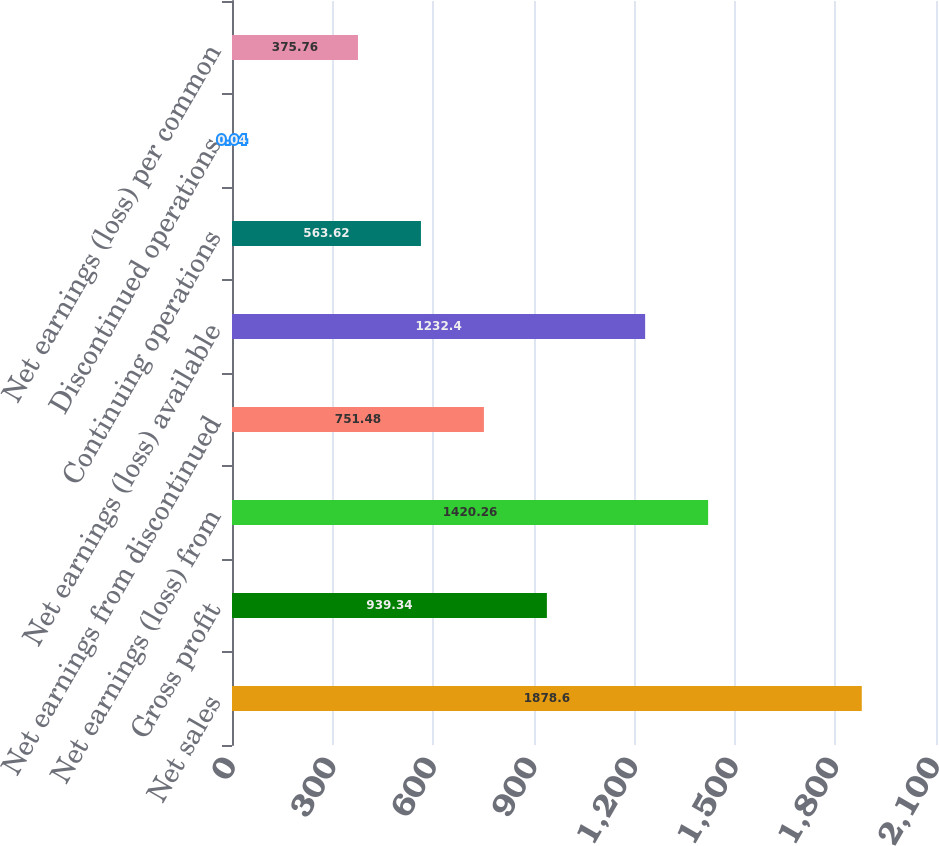Convert chart to OTSL. <chart><loc_0><loc_0><loc_500><loc_500><bar_chart><fcel>Net sales<fcel>Gross profit<fcel>Net earnings (loss) from<fcel>Net earnings from discontinued<fcel>Net earnings (loss) available<fcel>Continuing operations<fcel>Discontinued operations<fcel>Net earnings (loss) per common<nl><fcel>1878.6<fcel>939.34<fcel>1420.26<fcel>751.48<fcel>1232.4<fcel>563.62<fcel>0.04<fcel>375.76<nl></chart> 